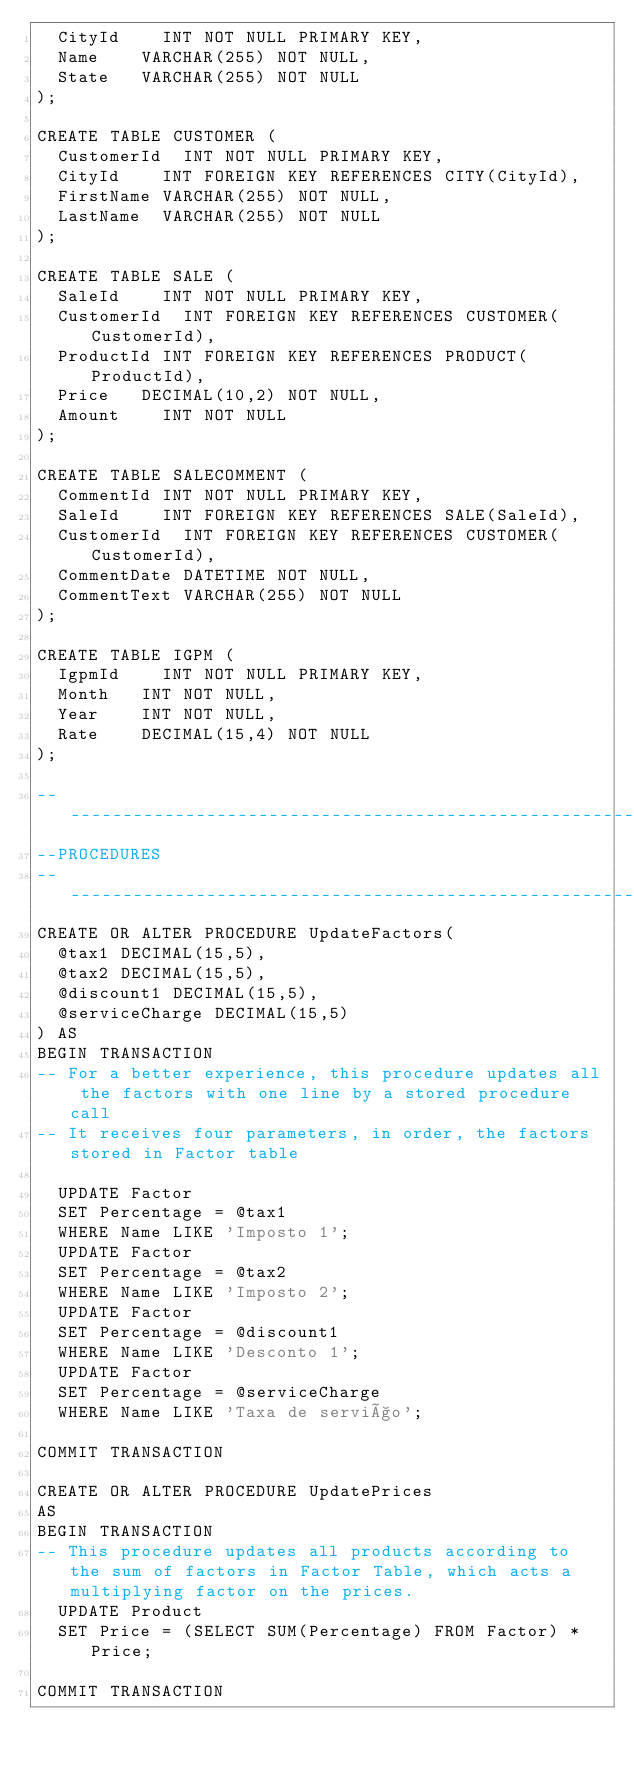Convert code to text. <code><loc_0><loc_0><loc_500><loc_500><_SQL_>	CityId		INT NOT NULL PRIMARY KEY,
	Name		VARCHAR(255) NOT NULL,
	State		VARCHAR(255) NOT NULL
);

CREATE TABLE CUSTOMER (
	CustomerId	INT NOT NULL PRIMARY KEY,
	CityId		INT FOREIGN KEY REFERENCES CITY(CityId),
	FirstName	VARCHAR(255) NOT NULL,	
	LastName	VARCHAR(255) NOT NULL
);

CREATE TABLE SALE (
	SaleId		INT NOT NULL PRIMARY KEY,
	CustomerId	INT FOREIGN KEY REFERENCES CUSTOMER(CustomerId),
	ProductId	INT FOREIGN KEY REFERENCES PRODUCT(ProductId),	
	Price		DECIMAL(10,2) NOT NULL,	
	Amount		INT NOT NULL
);

CREATE TABLE SALECOMMENT (
	CommentId	INT NOT NULL PRIMARY KEY,
	SaleId		INT FOREIGN KEY REFERENCES SALE(SaleId),
	CustomerId	INT FOREIGN KEY REFERENCES CUSTOMER(CustomerId),
	CommentDate	DATETIME NOT NULL,	
	CommentText	VARCHAR(255) NOT NULL
);

CREATE TABLE IGPM (
	IgpmId		INT NOT NULL PRIMARY KEY,
	Month		INT NOT NULL,
	Year		INT NOT NULL,
	Rate		DECIMAL(15,4) NOT NULL
);

------------------------------------------------------------
--PROCEDURES
------------------------------------------------------------
CREATE OR ALTER PROCEDURE UpdateFactors(
	@tax1 DECIMAL(15,5),
	@tax2 DECIMAL(15,5),
	@discount1 DECIMAL(15,5),
	@serviceCharge DECIMAL(15,5)
) AS
BEGIN TRANSACTION
-- For a better experience, this procedure updates all the factors with one line by a stored procedure call
-- It receives four parameters, in order, the factors stored in Factor table

	UPDATE Factor
	SET Percentage = @tax1	
	WHERE Name LIKE 'Imposto 1';
	UPDATE Factor
	SET Percentage = @tax2	
	WHERE Name LIKE 'Imposto 2';
	UPDATE Factor
	SET Percentage = @discount1	
	WHERE Name LIKE 'Desconto 1';
	UPDATE Factor
	SET Percentage = @serviceCharge	
	WHERE Name LIKE 'Taxa de serviço';
	
COMMIT TRANSACTION

CREATE OR ALTER PROCEDURE UpdatePrices
AS
BEGIN TRANSACTION
-- This procedure updates all products according to the sum of factors in Factor Table, which acts a multiplying factor on the prices. 
	UPDATE Product
	SET Price = (SELECT SUM(Percentage) FROM Factor) * Price;

COMMIT TRANSACTION
</code> 